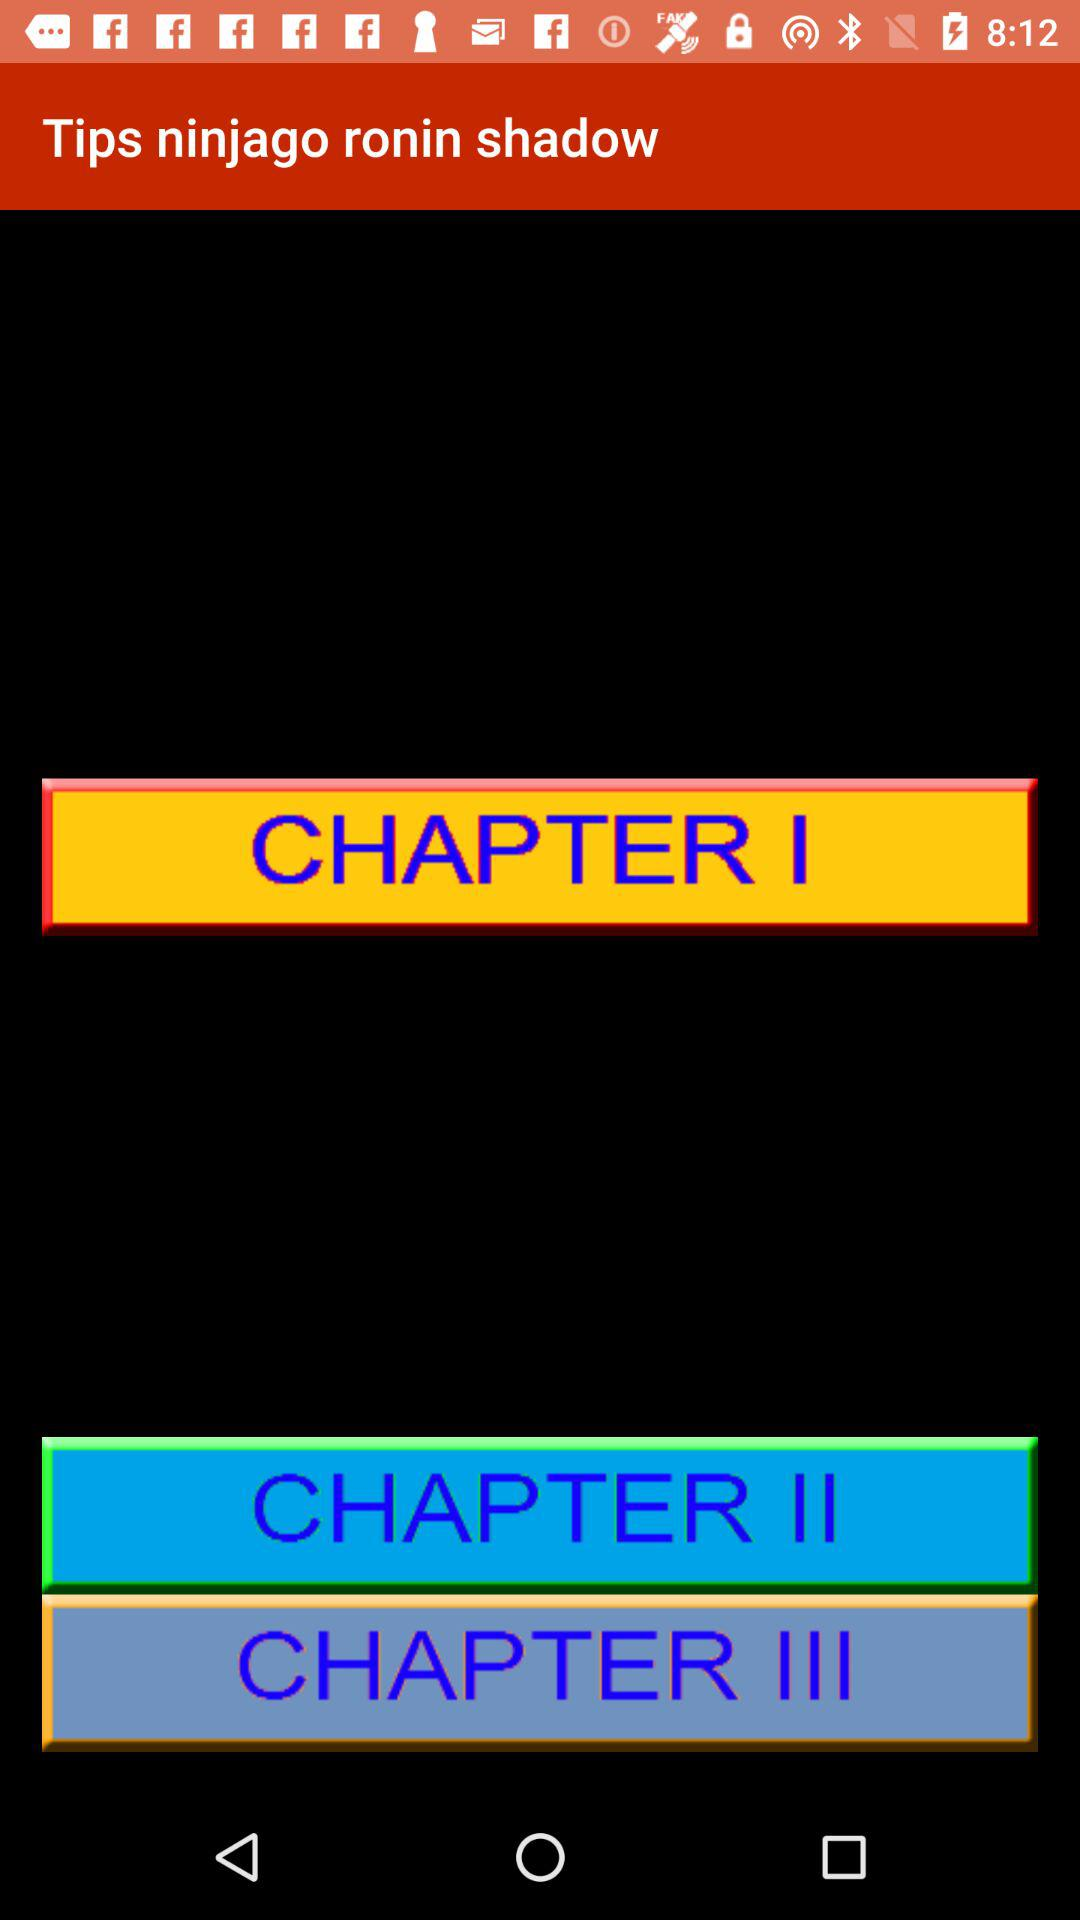How many chapters are there in the game?
Answer the question using a single word or phrase. 3 